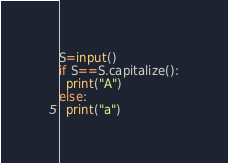Convert code to text. <code><loc_0><loc_0><loc_500><loc_500><_Python_>S=input()
if S==S.capitalize():
  print("A")
else:
  print("a")</code> 